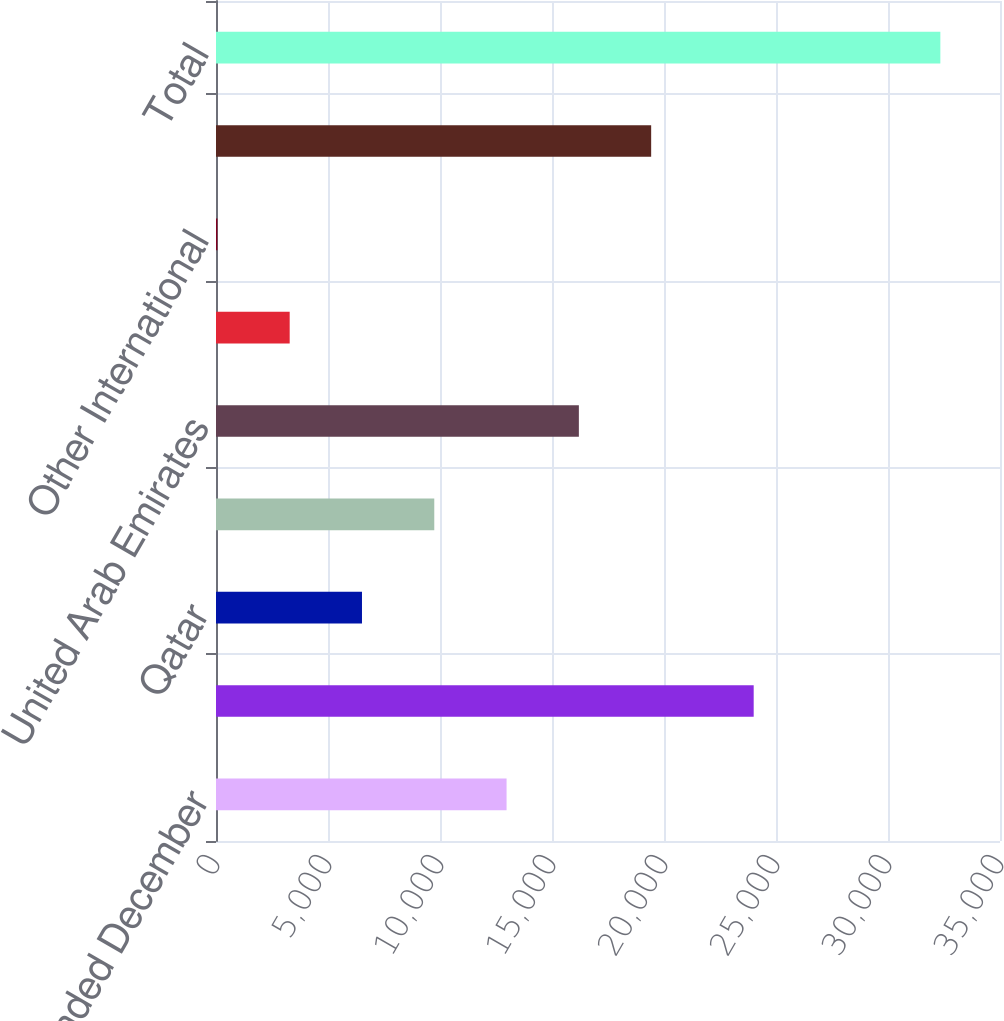<chart> <loc_0><loc_0><loc_500><loc_500><bar_chart><fcel>For the years ended December<fcel>United States<fcel>Qatar<fcel>Oman<fcel>United Arab Emirates<fcel>Colombia<fcel>Other International<fcel>Total International<fcel>Total<nl><fcel>12972<fcel>24004<fcel>6517<fcel>9744.5<fcel>16199.5<fcel>3289.5<fcel>62<fcel>19427<fcel>32337<nl></chart> 